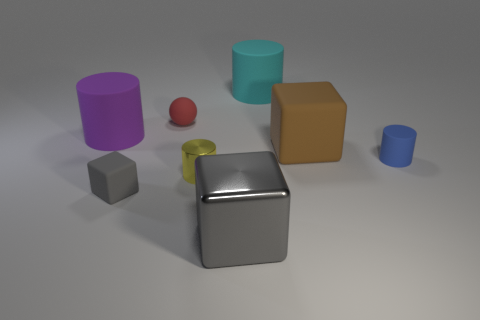Subtract all green cylinders. Subtract all red balls. How many cylinders are left? 4 Add 1 small purple metallic cubes. How many objects exist? 9 Subtract all spheres. How many objects are left? 7 Add 8 small red rubber spheres. How many small red rubber spheres are left? 9 Add 5 large purple objects. How many large purple objects exist? 6 Subtract 0 cyan balls. How many objects are left? 8 Subtract all small yellow shiny things. Subtract all cyan rubber cylinders. How many objects are left? 6 